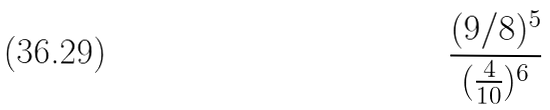<formula> <loc_0><loc_0><loc_500><loc_500>\frac { ( 9 / 8 ) ^ { 5 } } { ( \frac { 4 } { 1 0 } ) ^ { 6 } }</formula> 